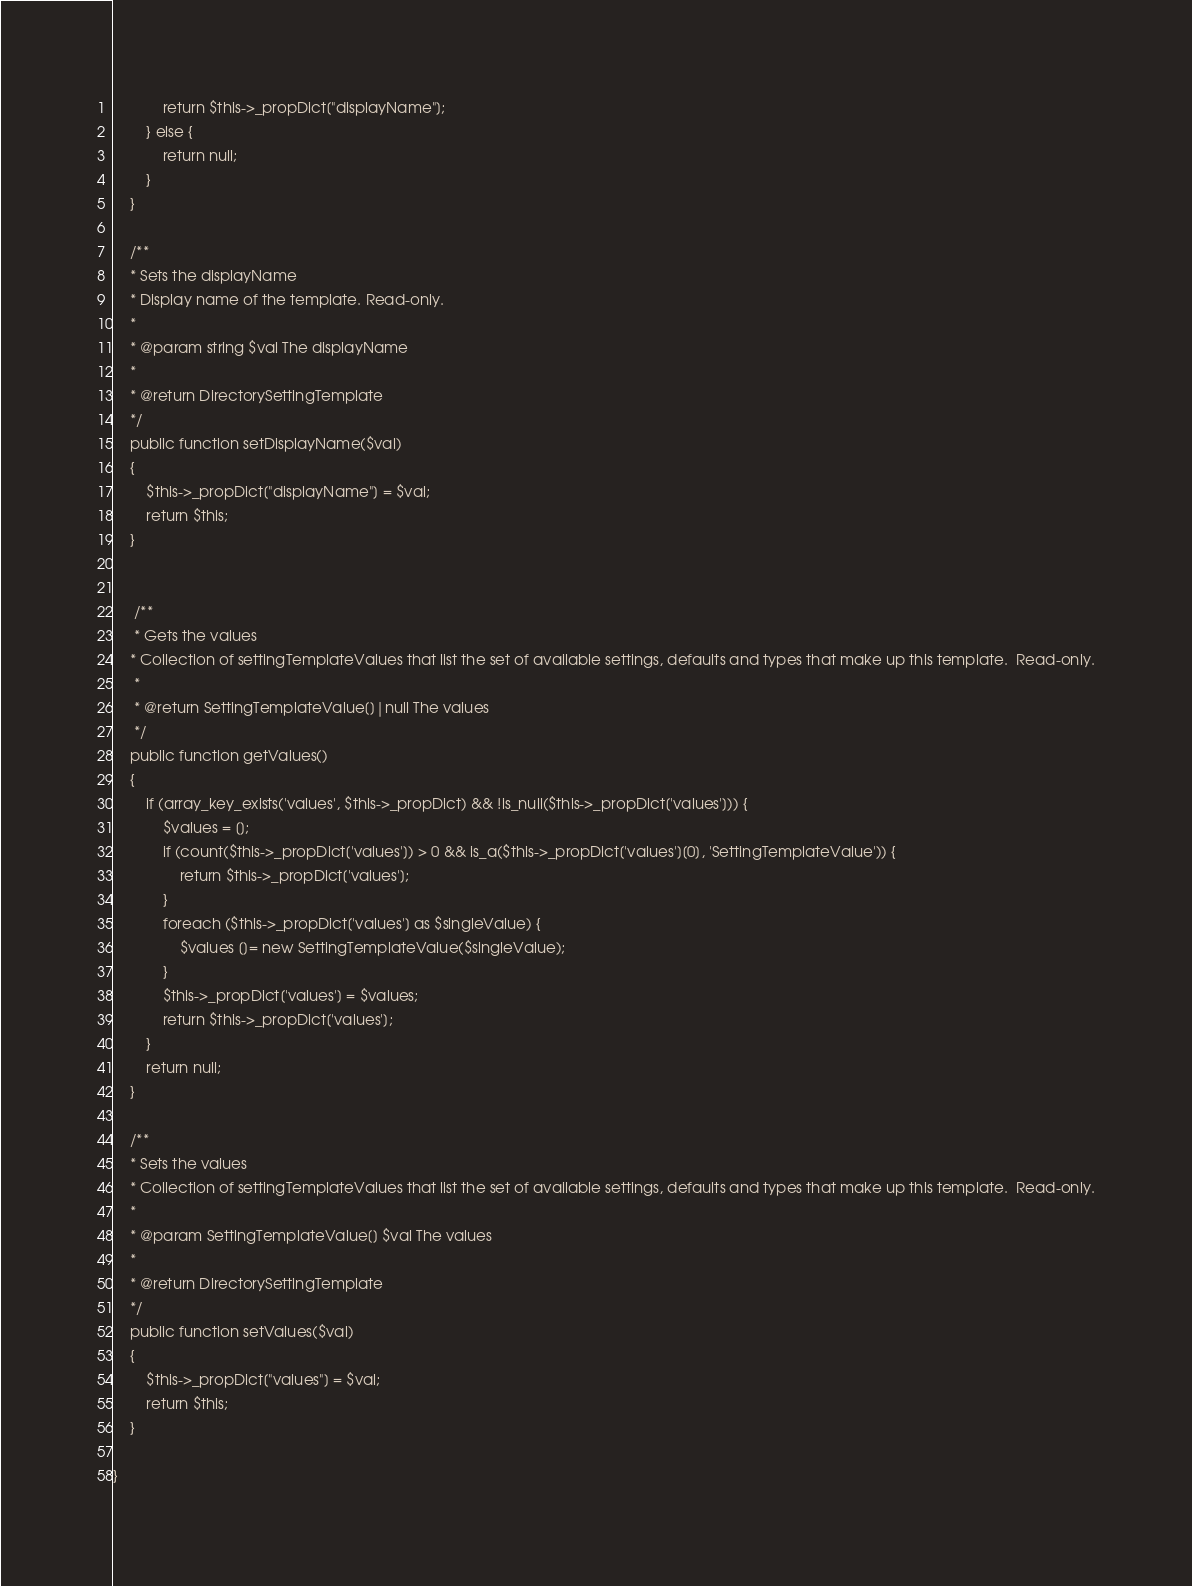<code> <loc_0><loc_0><loc_500><loc_500><_PHP_>            return $this->_propDict["displayName"];
        } else {
            return null;
        }
    }

    /**
    * Sets the displayName
    * Display name of the template. Read-only.
    *
    * @param string $val The displayName
    *
    * @return DirectorySettingTemplate
    */
    public function setDisplayName($val)
    {
        $this->_propDict["displayName"] = $val;
        return $this;
    }


     /**
     * Gets the values
    * Collection of settingTemplateValues that list the set of available settings, defaults and types that make up this template.  Read-only.
     *
     * @return SettingTemplateValue[]|null The values
     */
    public function getValues()
    {
        if (array_key_exists('values', $this->_propDict) && !is_null($this->_propDict['values'])) {
            $values = [];
            if (count($this->_propDict['values']) > 0 && is_a($this->_propDict['values'][0], 'SettingTemplateValue')) {
                return $this->_propDict['values'];
            }
            foreach ($this->_propDict['values'] as $singleValue) {
                $values []= new SettingTemplateValue($singleValue);
            }
            $this->_propDict['values'] = $values;
            return $this->_propDict['values'];
        }
        return null;
    }

    /**
    * Sets the values
    * Collection of settingTemplateValues that list the set of available settings, defaults and types that make up this template.  Read-only.
    *
    * @param SettingTemplateValue[] $val The values
    *
    * @return DirectorySettingTemplate
    */
    public function setValues($val)
    {
        $this->_propDict["values"] = $val;
        return $this;
    }

}
</code> 